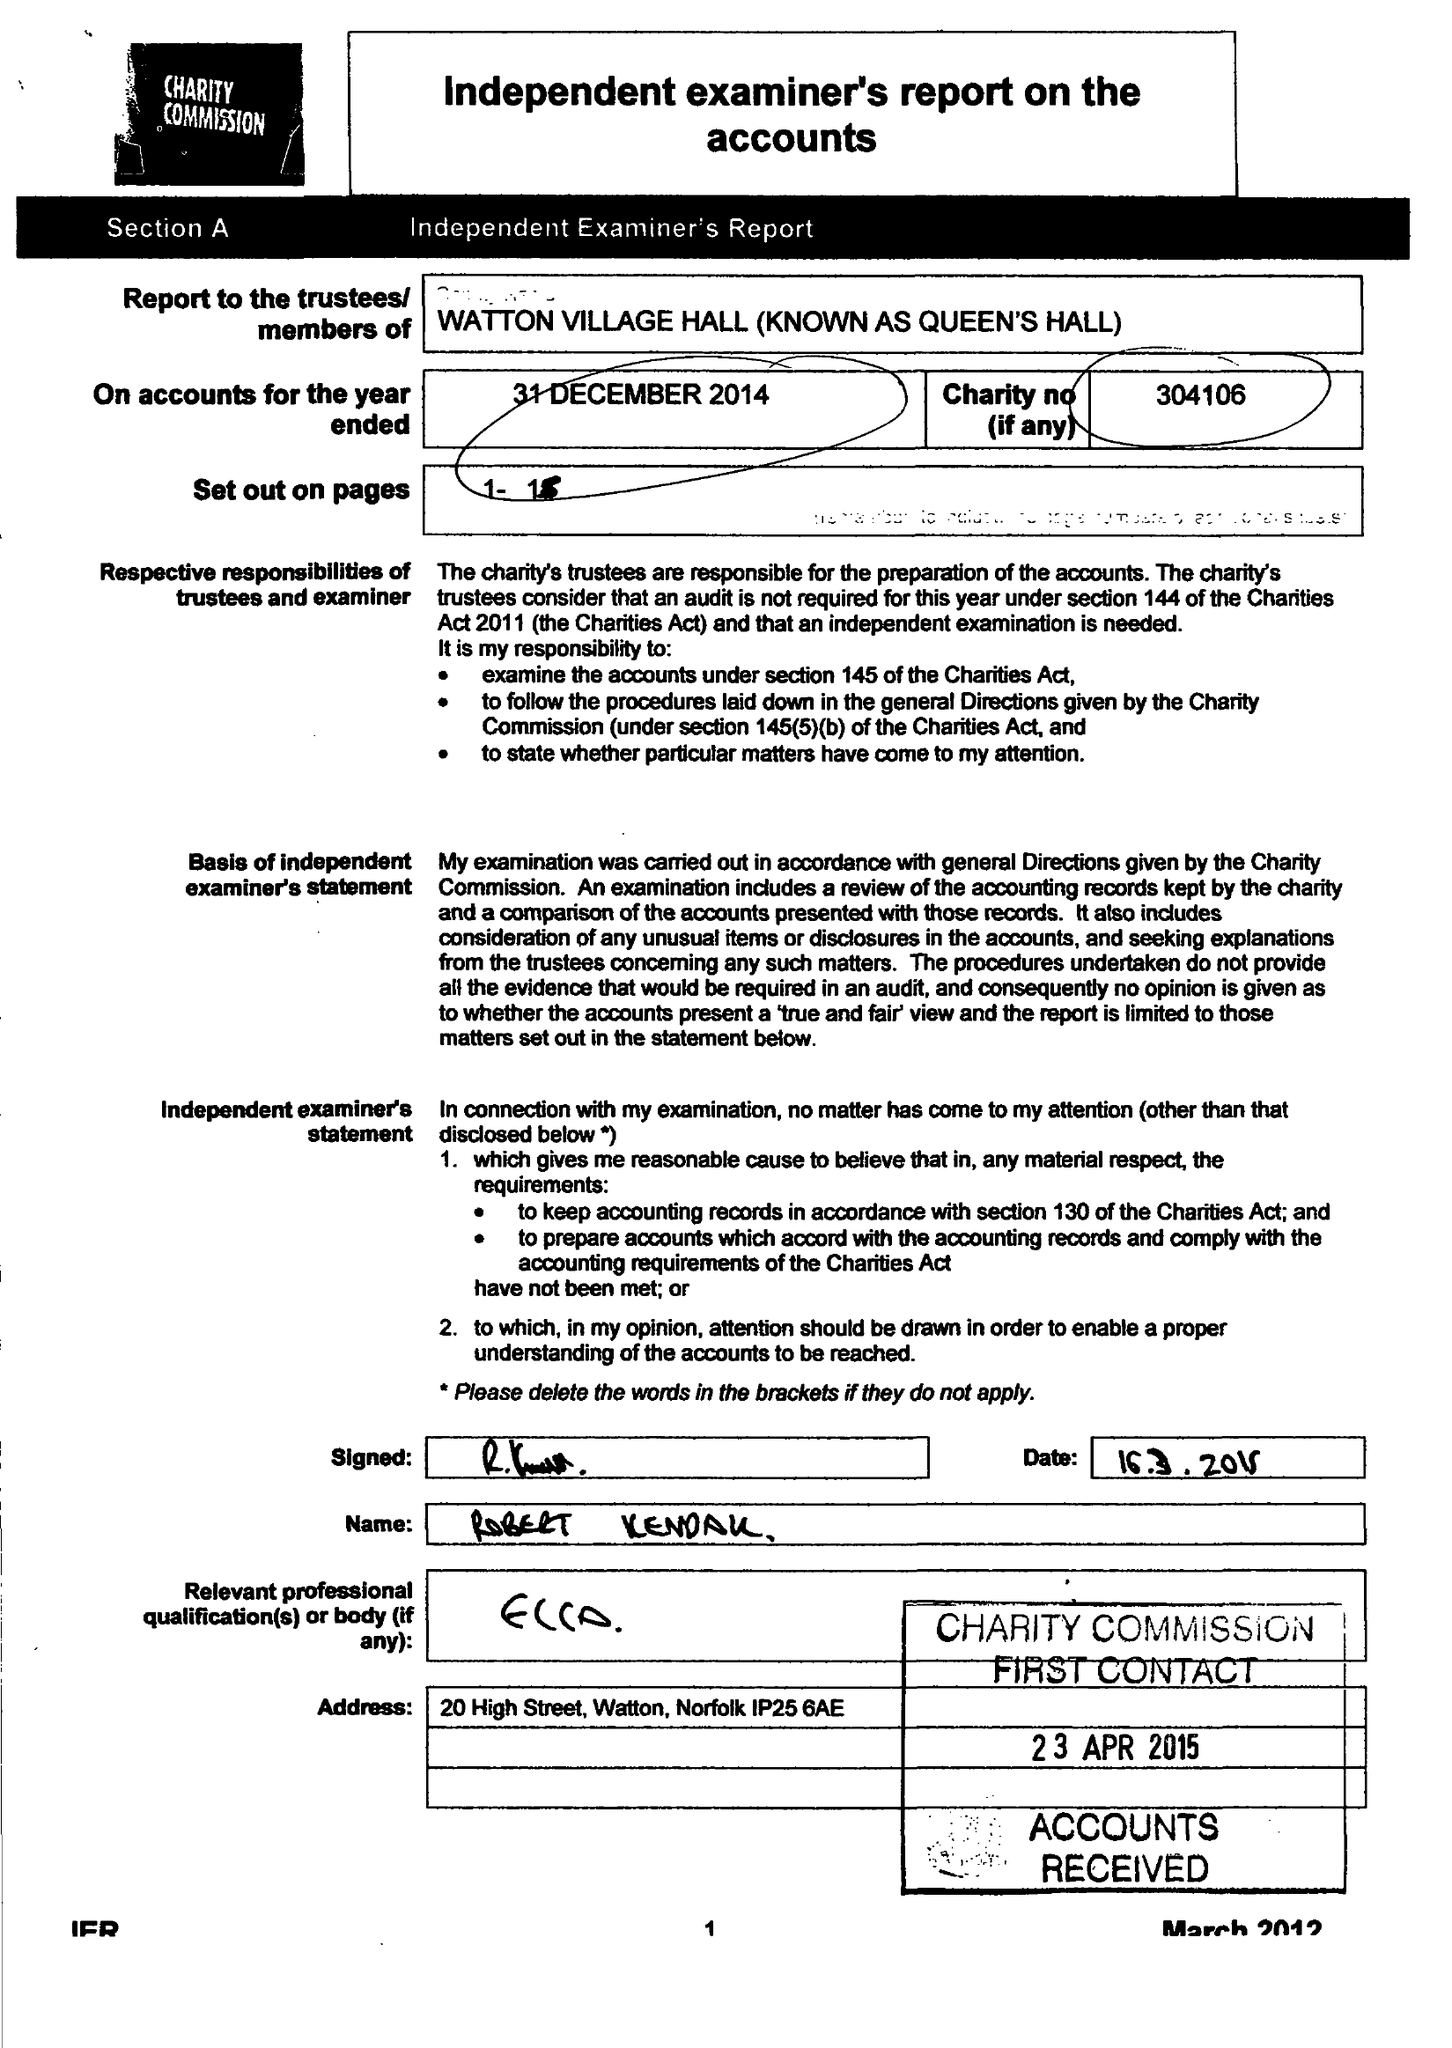What is the value for the address__post_town?
Answer the question using a single word or phrase. THETFORD 